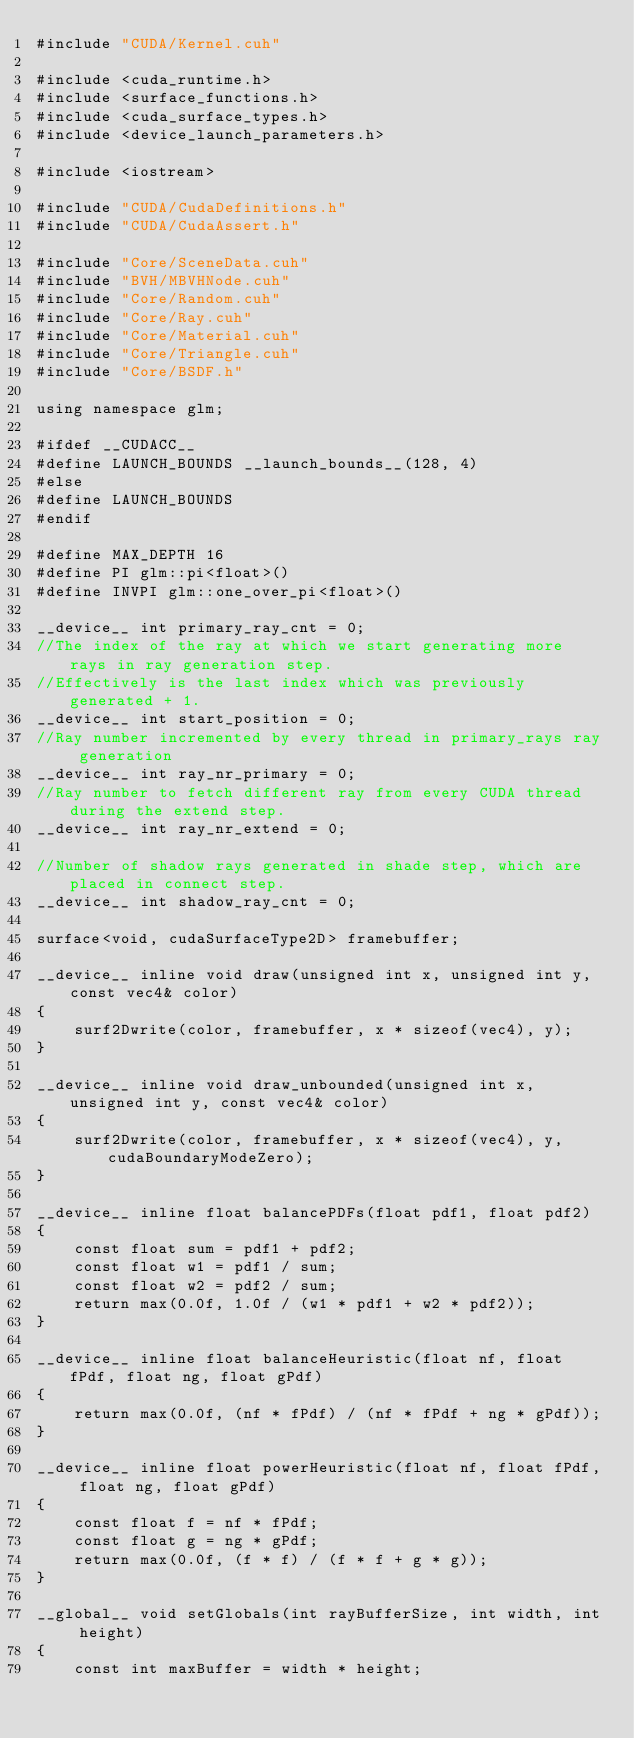<code> <loc_0><loc_0><loc_500><loc_500><_Cuda_>#include "CUDA/Kernel.cuh"

#include <cuda_runtime.h>
#include <surface_functions.h>
#include <cuda_surface_types.h>
#include <device_launch_parameters.h>

#include <iostream>

#include "CUDA/CudaDefinitions.h"
#include "CUDA/CudaAssert.h"

#include "Core/SceneData.cuh"
#include "BVH/MBVHNode.cuh"
#include "Core/Random.cuh"
#include "Core/Ray.cuh"
#include "Core/Material.cuh"
#include "Core/Triangle.cuh"
#include "Core/BSDF.h"

using namespace glm;

#ifdef __CUDACC__
#define LAUNCH_BOUNDS __launch_bounds__(128, 4)
#else
#define LAUNCH_BOUNDS
#endif

#define MAX_DEPTH 16
#define PI glm::pi<float>()
#define INVPI glm::one_over_pi<float>()

__device__ int primary_ray_cnt = 0;
//The index of the ray at which we start generating more rays in ray generation step.
//Effectively is the last index which was previously generated + 1.
__device__ int start_position = 0;
//Ray number incremented by every thread in primary_rays ray generation
__device__ int ray_nr_primary = 0;
//Ray number to fetch different ray from every CUDA thread during the extend step.
__device__ int ray_nr_extend = 0;

//Number of shadow rays generated in shade step, which are placed in connect step.
__device__ int shadow_ray_cnt = 0;

surface<void, cudaSurfaceType2D> framebuffer;

__device__ inline void draw(unsigned int x, unsigned int y, const vec4& color)
{
	surf2Dwrite(color, framebuffer, x * sizeof(vec4), y);
}

__device__ inline void draw_unbounded(unsigned int x, unsigned int y, const vec4& color)
{
	surf2Dwrite(color, framebuffer, x * sizeof(vec4), y, cudaBoundaryModeZero);
}

__device__ inline float balancePDFs(float pdf1, float pdf2)
{
	const float sum = pdf1 + pdf2;
	const float w1 = pdf1 / sum;
	const float w2 = pdf2 / sum;
	return max(0.0f, 1.0f / (w1 * pdf1 + w2 * pdf2));
}

__device__ inline float balanceHeuristic(float nf, float fPdf, float ng, float gPdf)
{
	return max(0.0f, (nf * fPdf) / (nf * fPdf + ng * gPdf));
}

__device__ inline float powerHeuristic(float nf, float fPdf, float ng, float gPdf)
{
	const float f = nf * fPdf;
	const float g = ng * gPdf;
	return max(0.0f, (f * f) / (f * f + g * g));
}

__global__ void setGlobals(int rayBufferSize, int width, int height)
{
	const int maxBuffer = width * height;</code> 